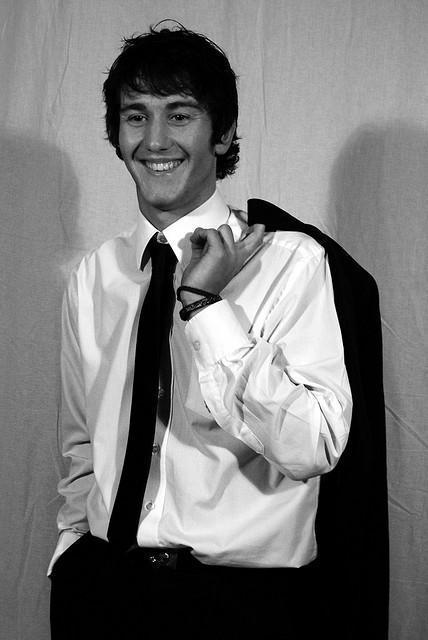How many cats are meowing on a bed?
Give a very brief answer. 0. 